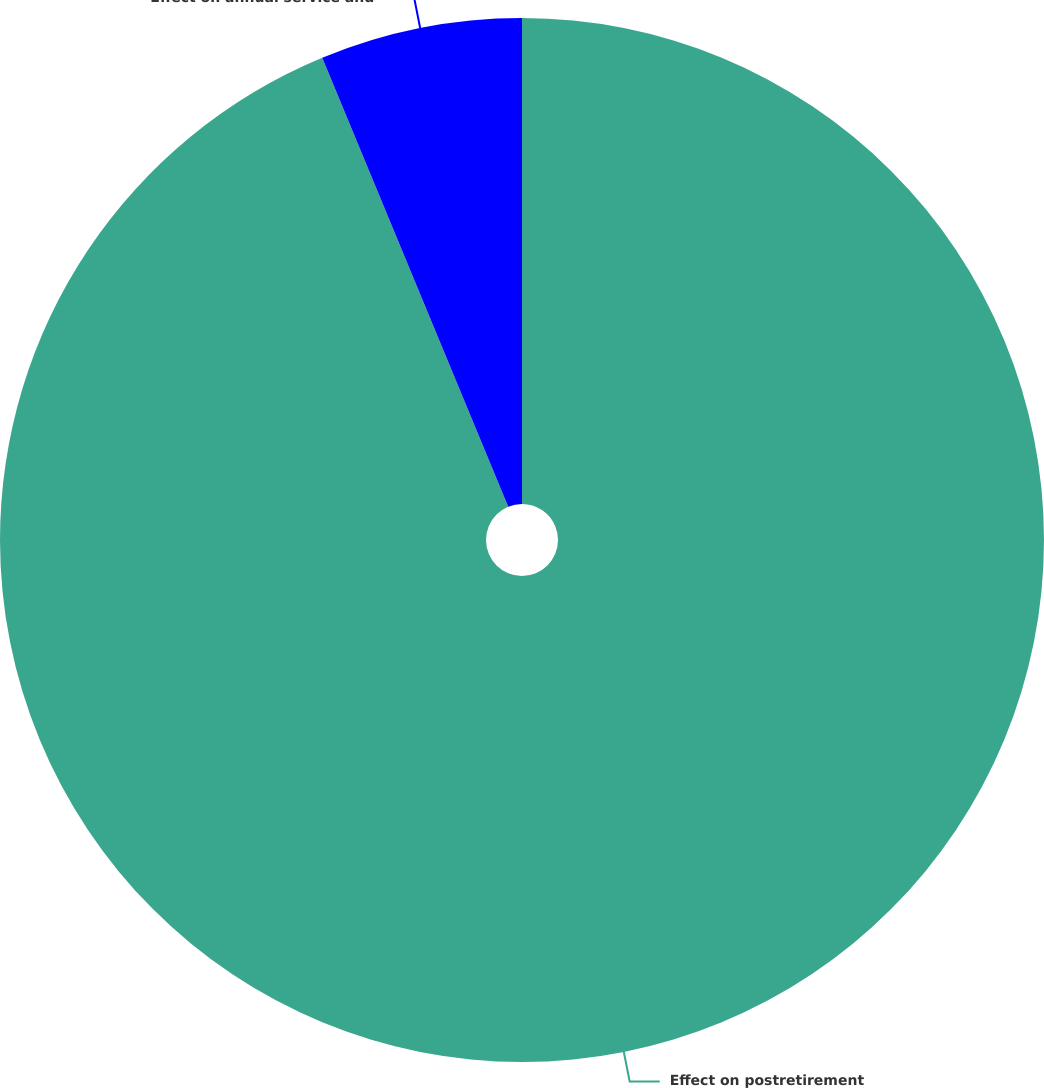Convert chart to OTSL. <chart><loc_0><loc_0><loc_500><loc_500><pie_chart><fcel>Effect on postretirement<fcel>Effect on annual service and<nl><fcel>93.75%<fcel>6.25%<nl></chart> 